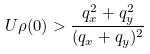<formula> <loc_0><loc_0><loc_500><loc_500>U \rho ( 0 ) > \frac { q ^ { 2 } _ { x } + q ^ { 2 } _ { y } } { ( q _ { x } + q _ { y } ) ^ { 2 } }</formula> 